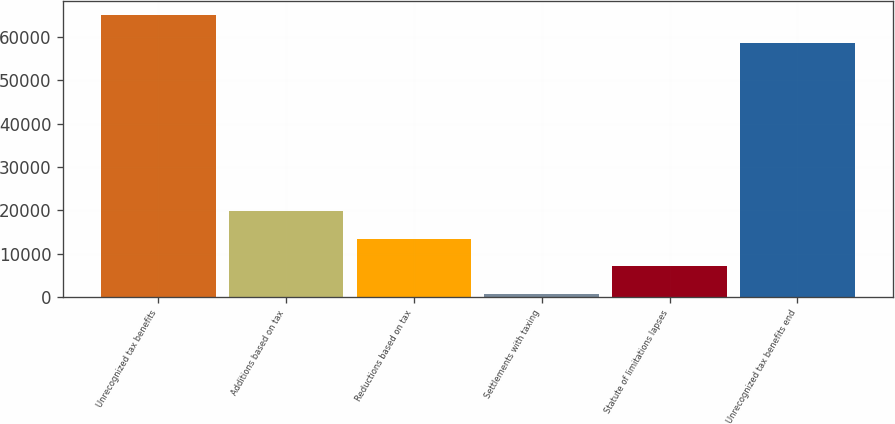<chart> <loc_0><loc_0><loc_500><loc_500><bar_chart><fcel>Unrecognized tax benefits<fcel>Additions based on tax<fcel>Reductions based on tax<fcel>Settlements with taxing<fcel>Statute of limitations lapses<fcel>Unrecognized tax benefits end<nl><fcel>65093.4<fcel>19873.2<fcel>13475.8<fcel>681<fcel>7078.4<fcel>58696<nl></chart> 